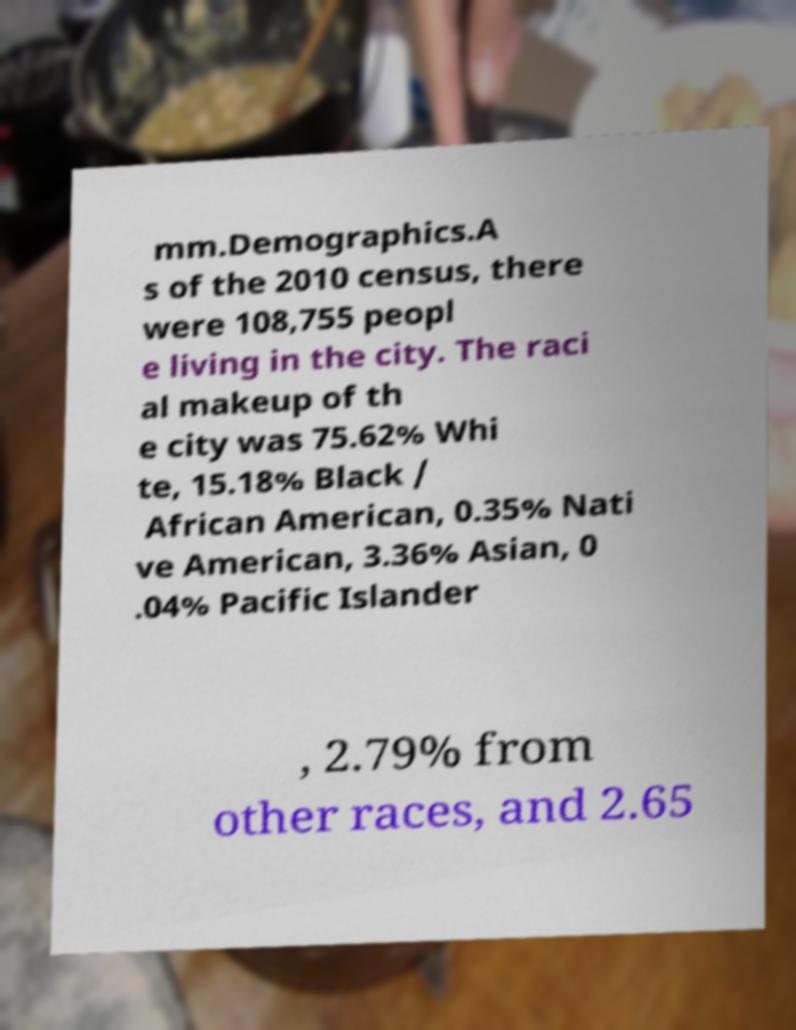What messages or text are displayed in this image? I need them in a readable, typed format. mm.Demographics.A s of the 2010 census, there were 108,755 peopl e living in the city. The raci al makeup of th e city was 75.62% Whi te, 15.18% Black / African American, 0.35% Nati ve American, 3.36% Asian, 0 .04% Pacific Islander , 2.79% from other races, and 2.65 